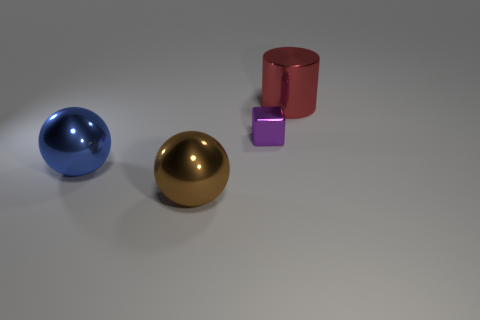Are there any other things that are the same size as the purple metallic block?
Your answer should be very brief. No. There is a cylinder that is the same material as the tiny thing; what is its color?
Make the answer very short. Red. Is the number of blue balls less than the number of balls?
Offer a terse response. Yes. What material is the big thing that is both behind the brown thing and in front of the red cylinder?
Your response must be concise. Metal. Is there a large object left of the large ball that is on the left side of the brown thing?
Offer a terse response. No. How many tiny metal blocks have the same color as the metallic cylinder?
Your response must be concise. 0. Does the cylinder have the same material as the big blue thing?
Provide a succinct answer. Yes. There is a block; are there any big cylinders on the left side of it?
Your answer should be very brief. No. There is a large ball that is behind the brown metallic object that is in front of the small purple metal block; what is its material?
Your response must be concise. Metal. There is another metal object that is the same shape as the big blue metallic object; what is its size?
Your answer should be very brief. Large. 